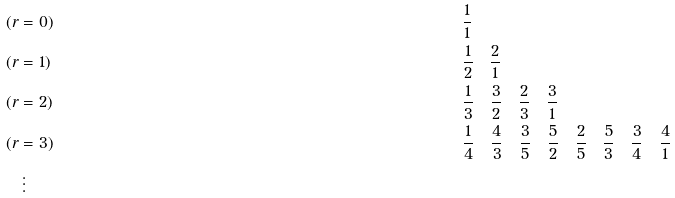<formula> <loc_0><loc_0><loc_500><loc_500>& ( r = 0 ) & \quad & \frac { 1 } { 1 } \\ & ( r = 1 ) & \quad & \frac { 1 } { 2 } \quad \frac { 2 } { 1 } \\ & ( r = 2 ) & \quad & \frac { 1 } { 3 } \quad \frac { 3 } { 2 } \quad \frac { 2 } { 3 } \quad \frac { 3 } { 1 } \\ & ( r = 3 ) & \quad & \frac { 1 } { 4 } \quad \frac { 4 } { 3 } \quad \frac { 3 } { 5 } \quad \frac { 5 } { 2 } \quad \frac { 2 } { 5 } \quad \frac { 5 } { 3 } \quad \frac { 3 } { 4 } \quad \frac { 4 } { 1 } \\ & \quad \vdots \\</formula> 